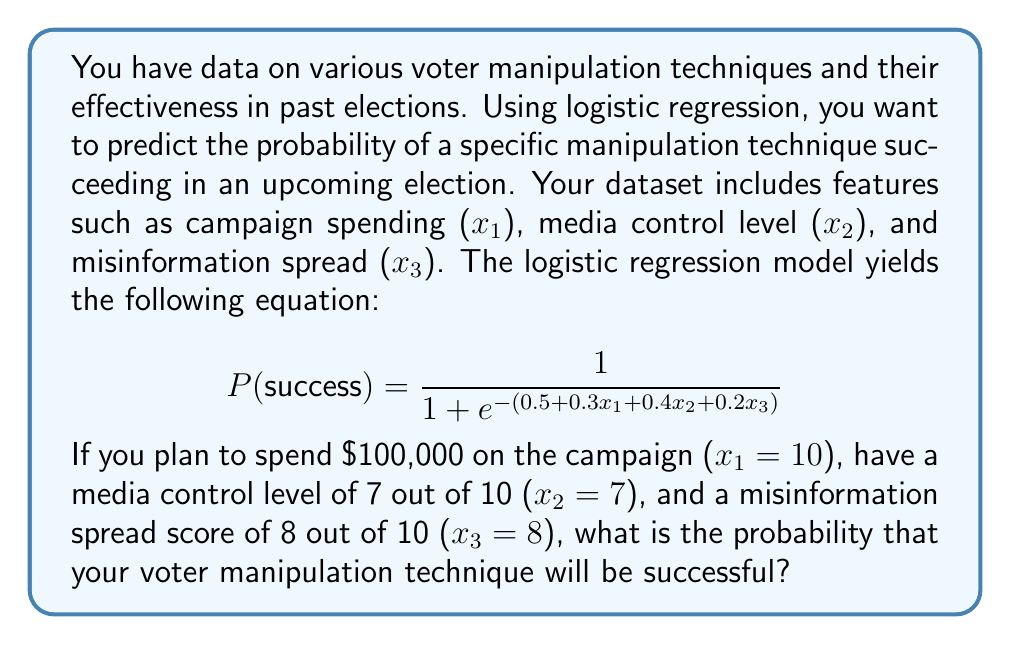Give your solution to this math problem. To solve this problem, we need to follow these steps:

1. Identify the logistic regression equation:
   $$ P(success) = \frac{1}{1 + e^{-(0.5 + 0.3x_1 + 0.4x_2 + 0.2x_3)}} $$

2. Substitute the given values into the equation:
   - x1 = 10 (campaign spending of $100,000, assuming the unit is in tens of thousands)
   - x2 = 7 (media control level)
   - x3 = 8 (misinformation spread score)

3. Calculate the exponent:
   $0.5 + 0.3(10) + 0.4(7) + 0.2(8)$
   $= 0.5 + 3 + 2.8 + 1.6$
   $= 7.9$

4. Substitute this value into the logistic function:
   $$ P(success) = \frac{1}{1 + e^{-7.9}} $$

5. Calculate the final probability:
   $$ P(success) = \frac{1}{1 + e^{-7.9}} \approx 0.9996 $$

The probability is very close to 1, indicating a high likelihood of success for the voter manipulation technique given these input values.
Answer: The probability that the voter manipulation technique will be successful is approximately 0.9996 or 99.96%. 